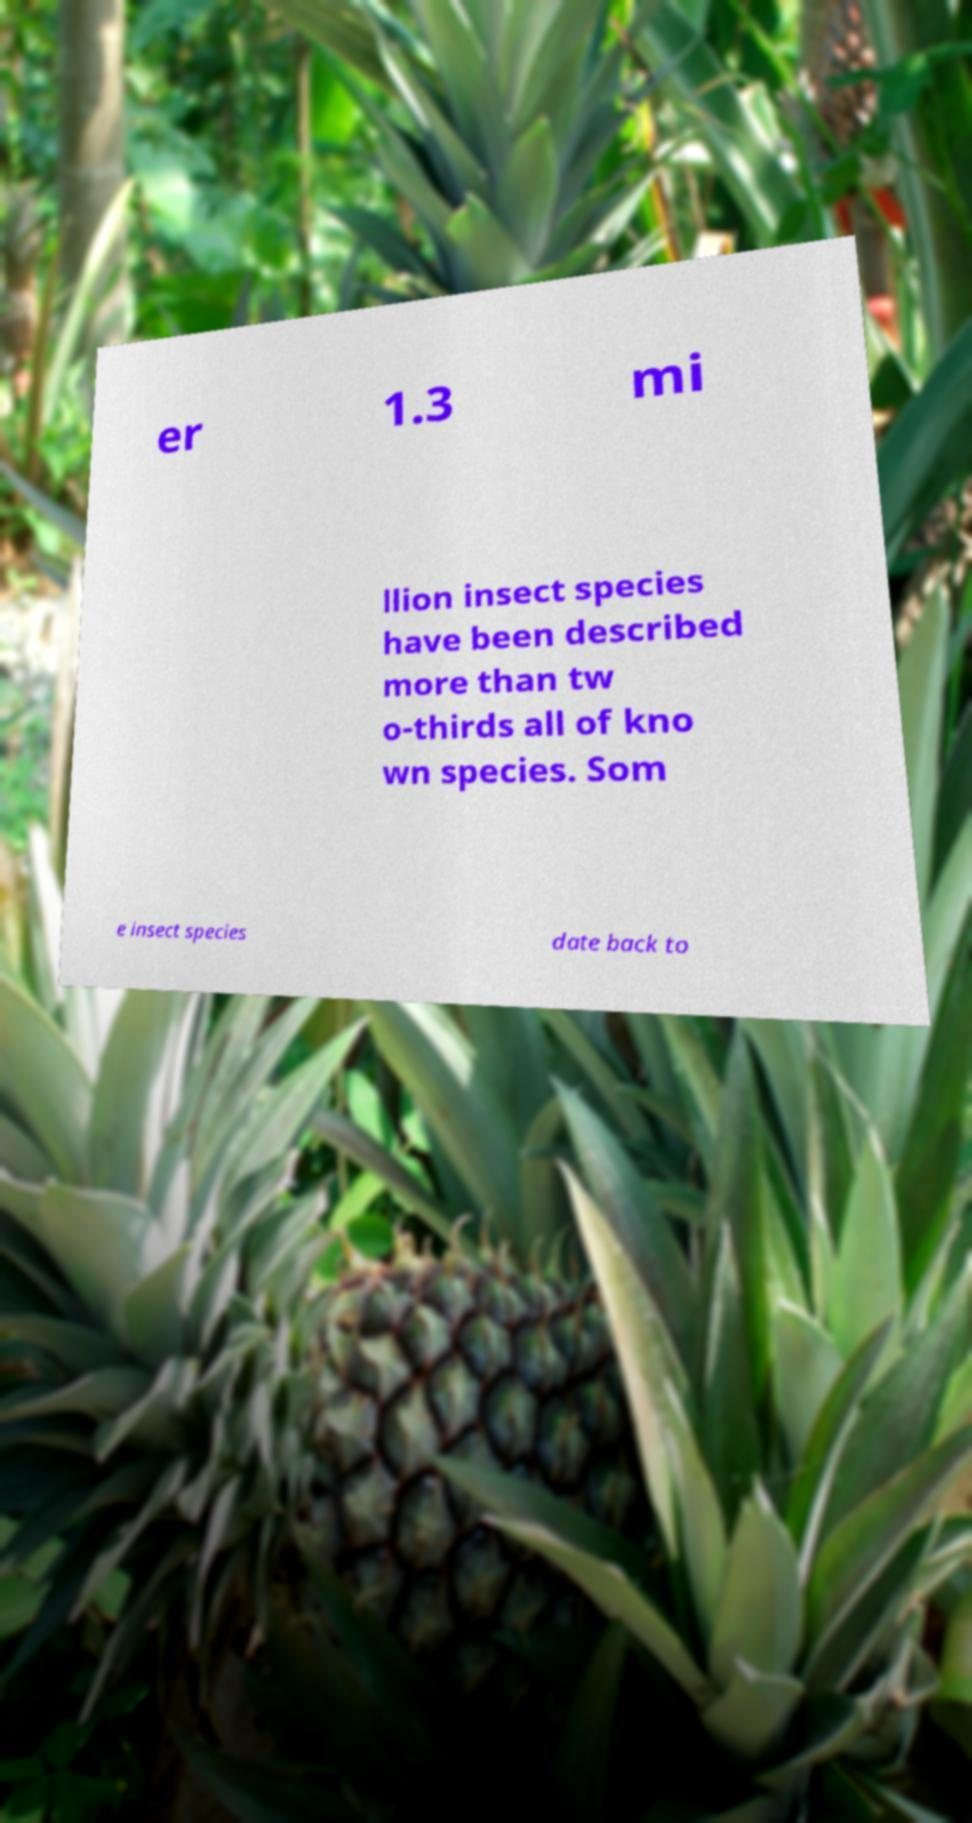For documentation purposes, I need the text within this image transcribed. Could you provide that? er 1.3 mi llion insect species have been described more than tw o-thirds all of kno wn species. Som e insect species date back to 